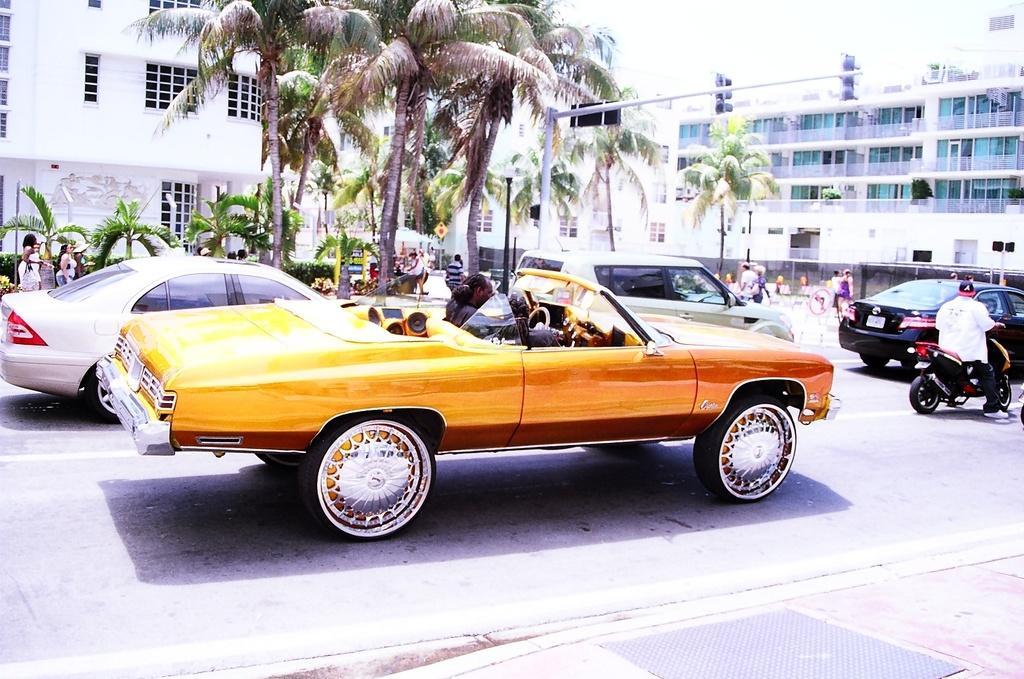Can you describe this image briefly? This image is clicked outside. There are trees in the middle, there are buildings on the right side and left side. There are cars in the middle. There is a person on motorcycle on the right side. There is sky on top. 